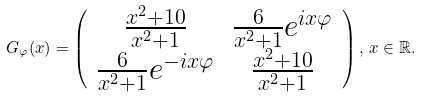Convert formula to latex. <formula><loc_0><loc_0><loc_500><loc_500>G _ { \varphi } ( x ) = \left ( \begin{array} { c c } \frac { x ^ { 2 } + 1 0 } { x ^ { 2 } + 1 } & \frac { 6 } { x ^ { 2 } + 1 } e ^ { i x \varphi } \\ \frac { 6 } { x ^ { 2 } + 1 } e ^ { - i x \varphi } & \frac { x ^ { 2 } + 1 0 } { x ^ { 2 } + 1 } \end{array} \right ) , \, x \in { \mathbb { R } } .</formula> 